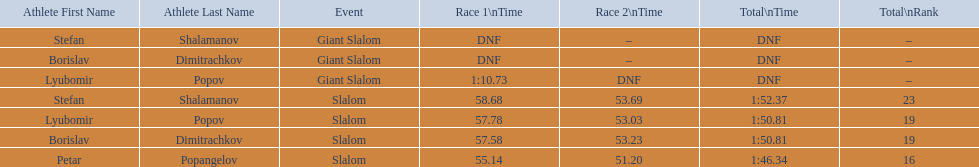Who was the other athlete who tied in rank with lyubomir popov? Borislav Dimitrachkov. 